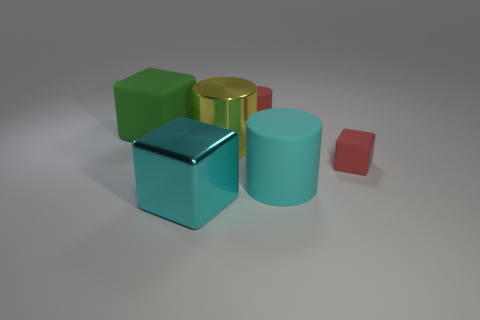Do the cyan metal object and the yellow metallic thing have the same shape?
Offer a very short reply. No. How many other things are the same size as the red matte cube?
Your answer should be very brief. 1. What is the color of the shiny cube?
Your answer should be compact. Cyan. How many tiny objects are green matte objects or red things?
Offer a terse response. 2. There is a cube that is on the left side of the big metal cube; does it have the same size as the cyan rubber thing that is in front of the big rubber cube?
Give a very brief answer. Yes. There is a red thing that is the same shape as the green object; what is its size?
Keep it short and to the point. Small. Are there more big cyan rubber things behind the green object than cyan cubes that are behind the large rubber cylinder?
Offer a terse response. No. There is a big thing that is in front of the large metal cylinder and right of the cyan metallic thing; what is it made of?
Ensure brevity in your answer.  Rubber. There is another matte object that is the same shape as the green matte thing; what color is it?
Your answer should be very brief. Red. How big is the cyan shiny object?
Offer a very short reply. Large. 